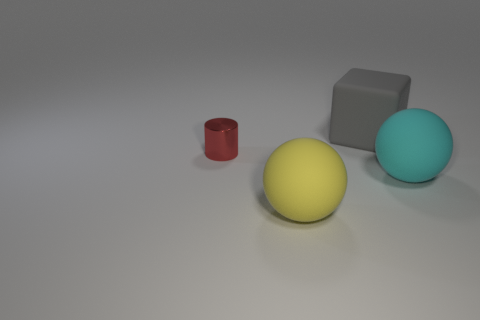How does the lighting affect the appearance of the objects? The lighting in the image casts soft shadows and highlights on the objects, enhancing their three-dimensional form. It appears to come from the upper left side, creating a gentle gradient across the surfaces. This lighting setup gives the objects a realistic appearance, highlighting the texture of the matte balls and the smoothness of the cube. 